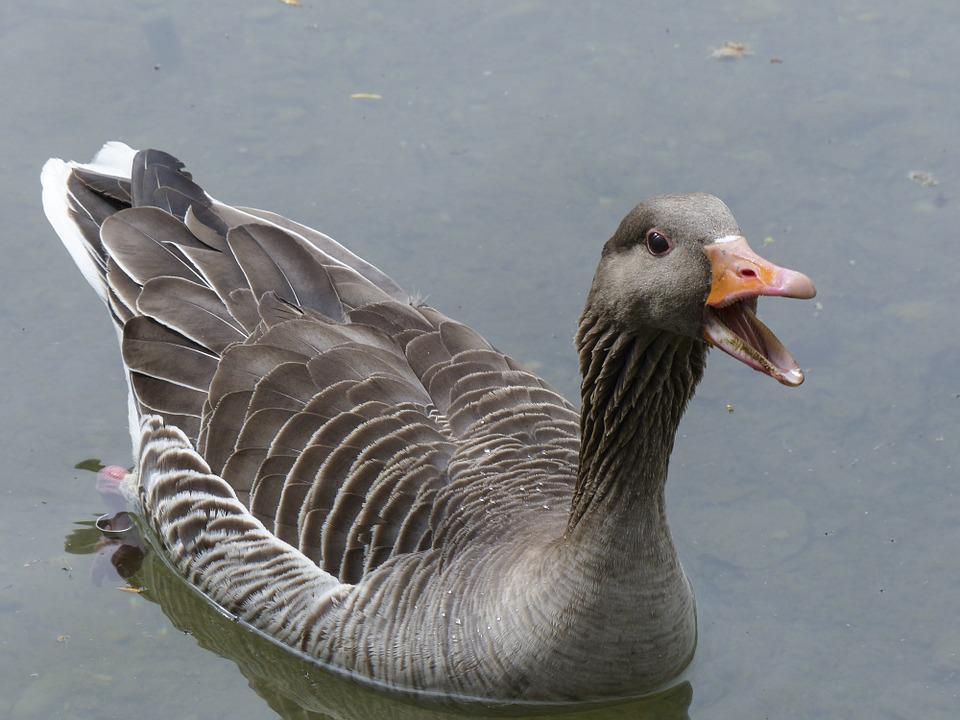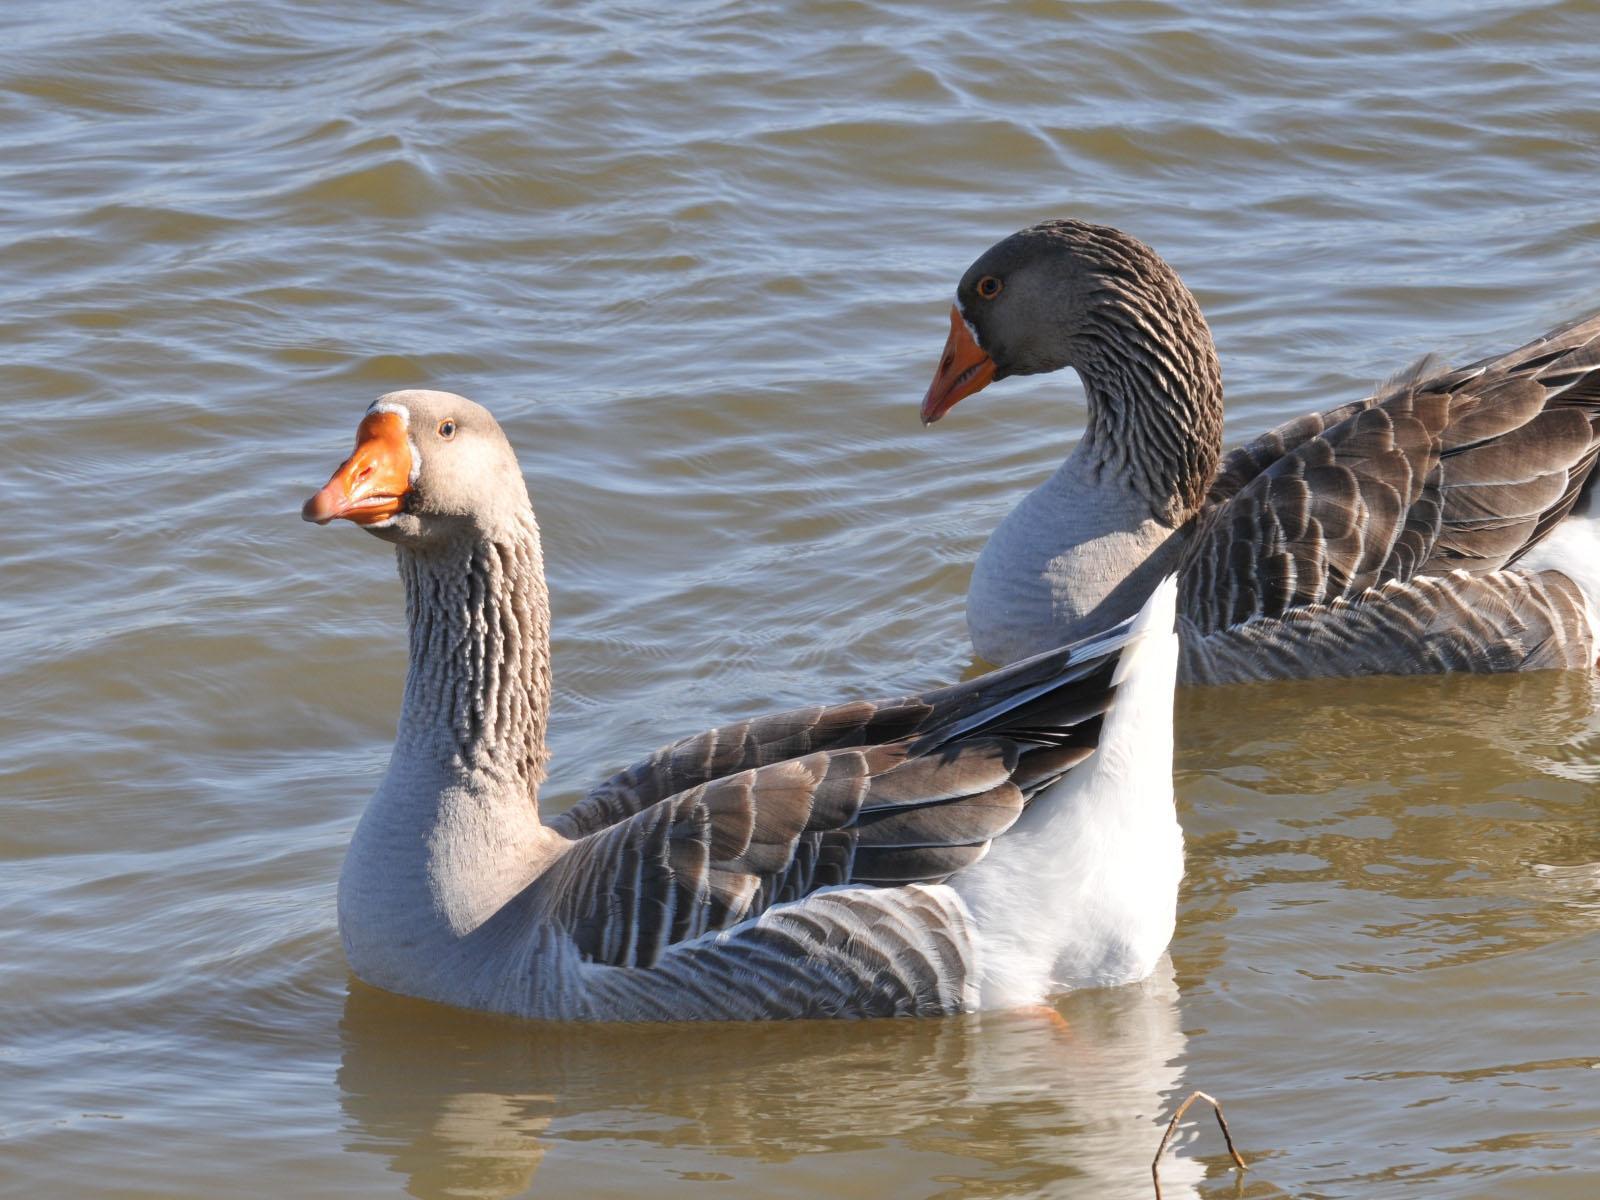The first image is the image on the left, the second image is the image on the right. Analyze the images presented: Is the assertion "More water fowl are shown in the right image." valid? Answer yes or no. Yes. 